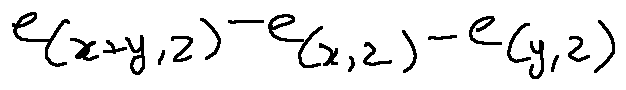Convert formula to latex. <formula><loc_0><loc_0><loc_500><loc_500>e _ { ( x + y , z ) } - e _ { ( x , z ) } - e _ { ( y , z ) }</formula> 